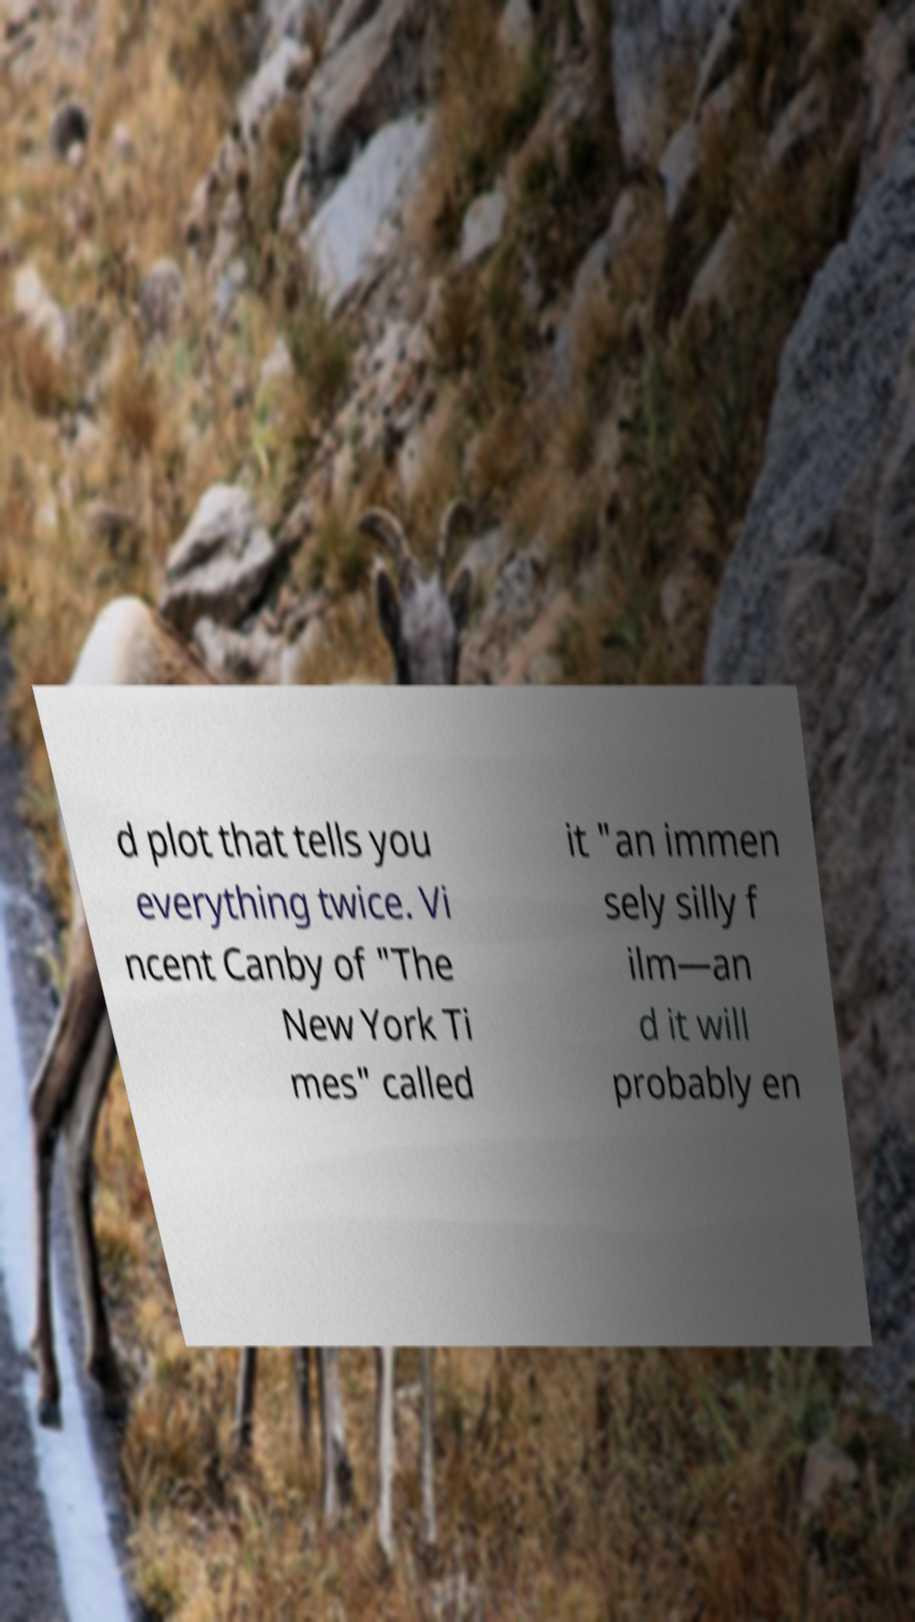Can you accurately transcribe the text from the provided image for me? d plot that tells you everything twice. Vi ncent Canby of "The New York Ti mes" called it "an immen sely silly f ilm—an d it will probably en 